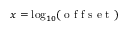Convert formula to latex. <formula><loc_0><loc_0><loc_500><loc_500>x = \log _ { 1 0 } ( o f f s e t )</formula> 